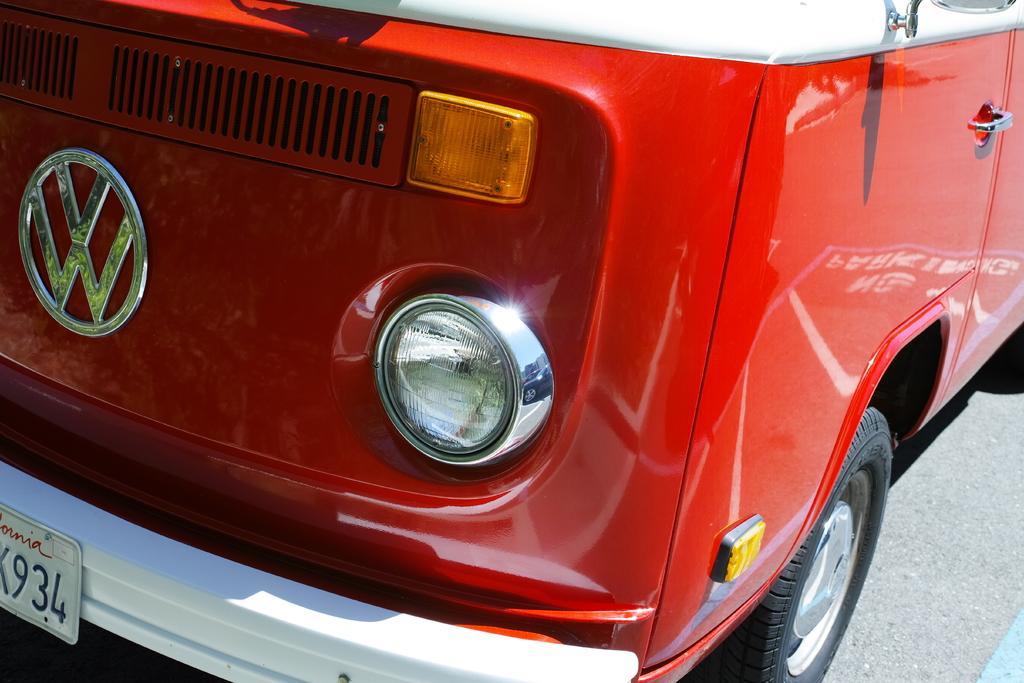Please provide a concise description of this image. In this image I can see red colour vehicle and here on this board I can see few numbers are written. 